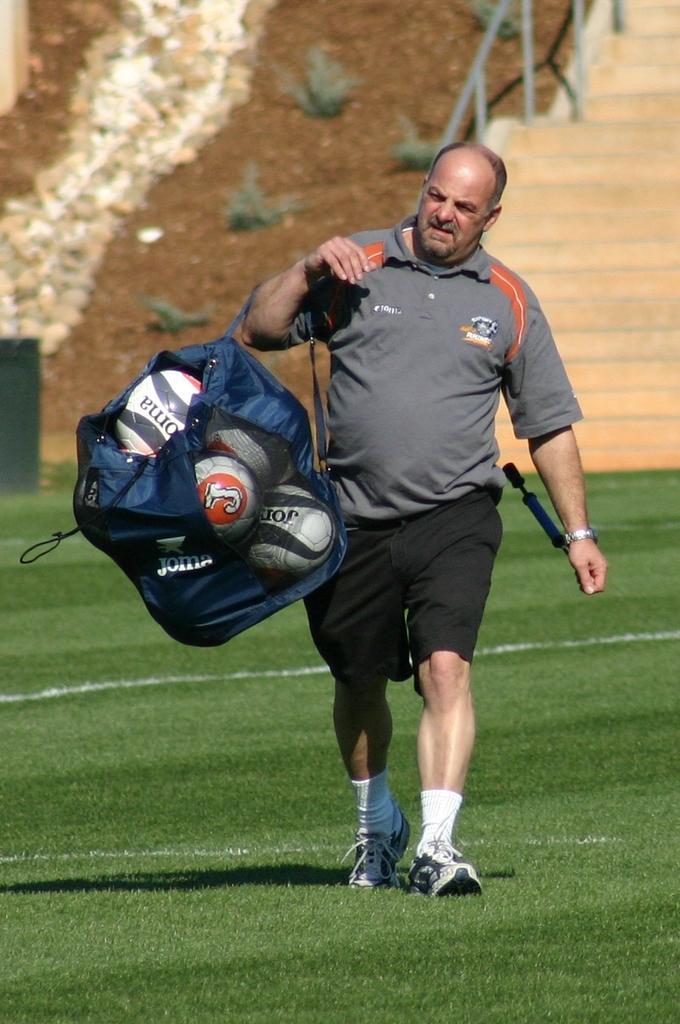Describe this image in one or two sentences. In this picture we can see a man is walking and carrying a bag, there are some balls in the bag, at the bottom there is grass, we can see plants, soil and stairs in the background. 